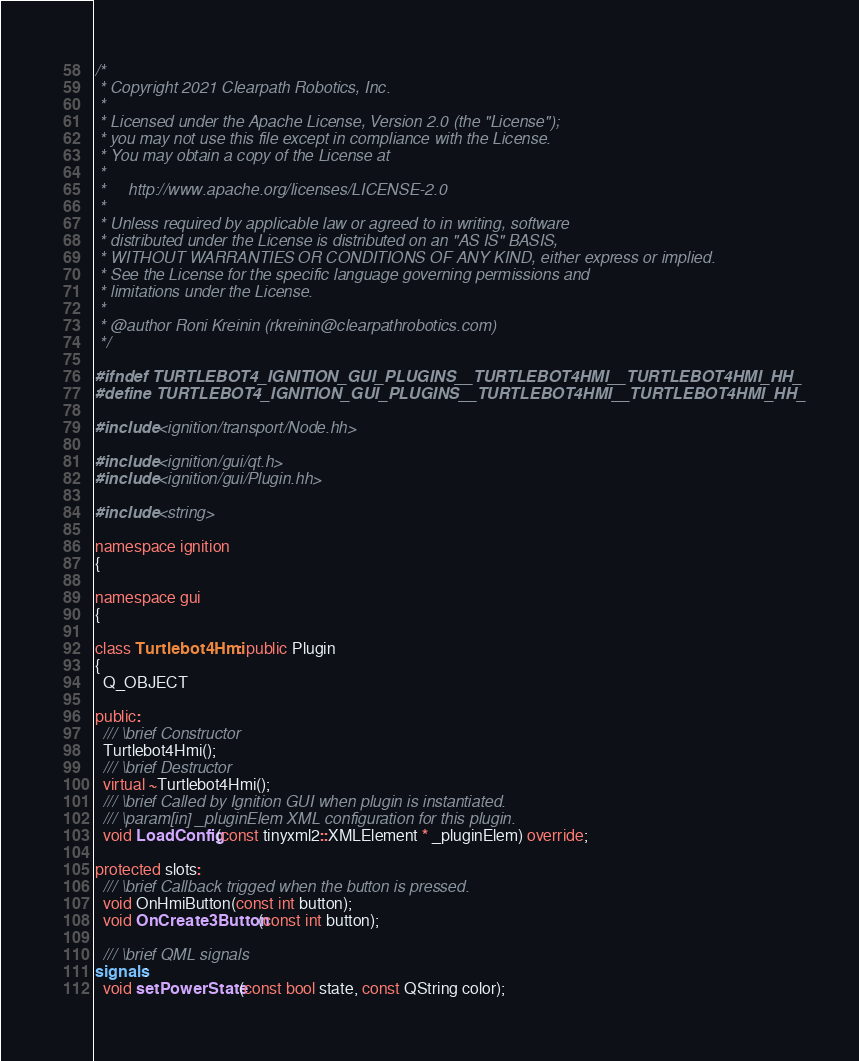<code> <loc_0><loc_0><loc_500><loc_500><_C++_>/*
 * Copyright 2021 Clearpath Robotics, Inc.
 *
 * Licensed under the Apache License, Version 2.0 (the "License");
 * you may not use this file except in compliance with the License.
 * You may obtain a copy of the License at
 *
 *     http://www.apache.org/licenses/LICENSE-2.0
 *
 * Unless required by applicable law or agreed to in writing, software
 * distributed under the License is distributed on an "AS IS" BASIS,
 * WITHOUT WARRANTIES OR CONDITIONS OF ANY KIND, either express or implied.
 * See the License for the specific language governing permissions and
 * limitations under the License.
 *
 * @author Roni Kreinin (rkreinin@clearpathrobotics.com)
 */

#ifndef TURTLEBOT4_IGNITION_GUI_PLUGINS__TURTLEBOT4HMI__TURTLEBOT4HMI_HH_
#define TURTLEBOT4_IGNITION_GUI_PLUGINS__TURTLEBOT4HMI__TURTLEBOT4HMI_HH_

#include <ignition/transport/Node.hh>

#include <ignition/gui/qt.h>
#include <ignition/gui/Plugin.hh>

#include <string>

namespace ignition
{

namespace gui
{

class Turtlebot4Hmi : public Plugin
{
  Q_OBJECT

public:
  /// \brief Constructor
  Turtlebot4Hmi();
  /// \brief Destructor
  virtual ~Turtlebot4Hmi();
  /// \brief Called by Ignition GUI when plugin is instantiated.
  /// \param[in] _pluginElem XML configuration for this plugin.
  void LoadConfig(const tinyxml2::XMLElement * _pluginElem) override;

protected slots:
  /// \brief Callback trigged when the button is pressed.
  void OnHmiButton(const int button);
  void OnCreate3Button(const int button);

  /// \brief QML signals
signals:
  void setPowerState(const bool state, const QString color);</code> 